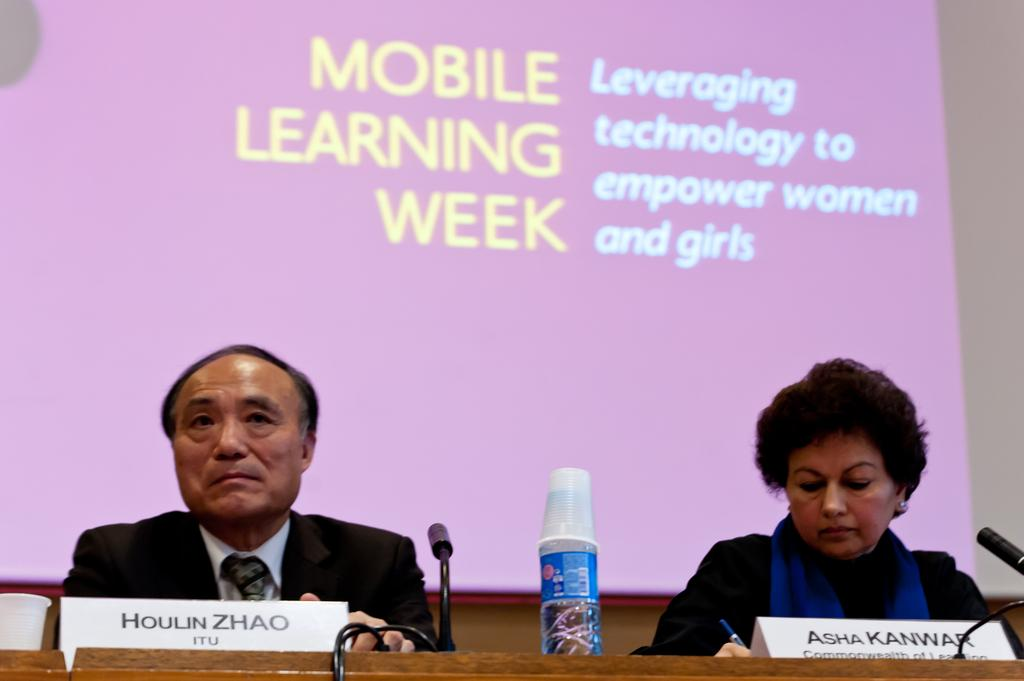<image>
Write a terse but informative summary of the picture. Two people at the Mobile Learning Week seminar. 